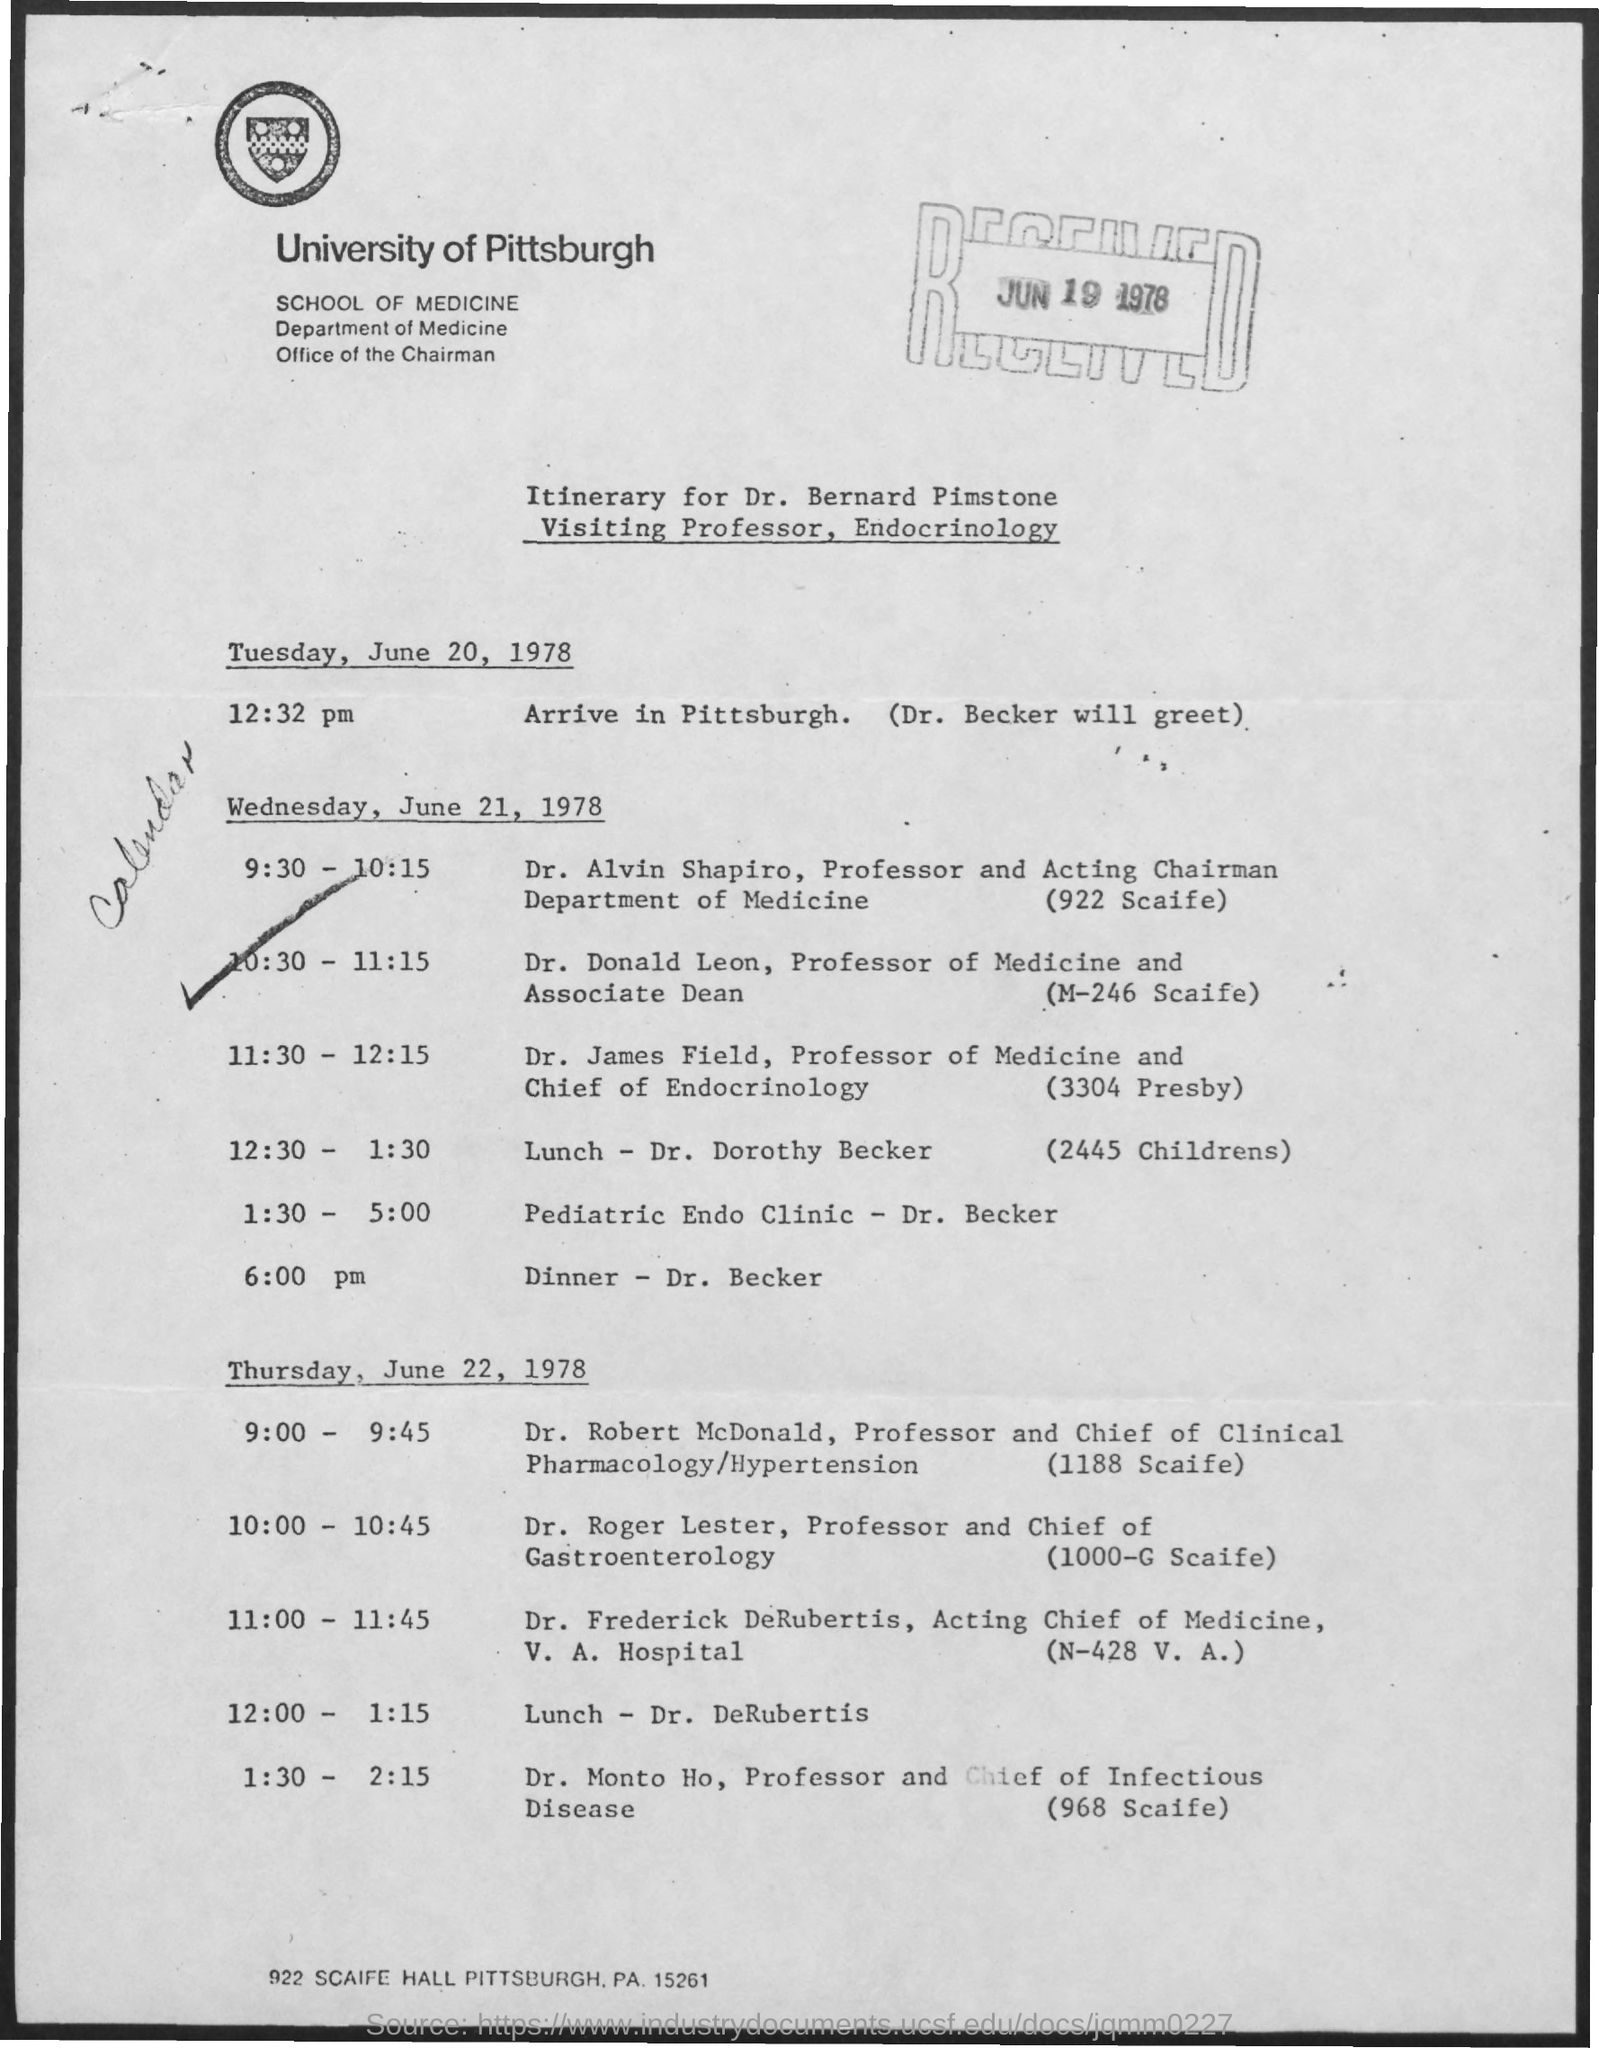What is the received date mentioned in the form ?
Your response must be concise. JUN 19 1978. What is the name of the university mentioned ?
Provide a short and direct response. University of pittsburgh. 